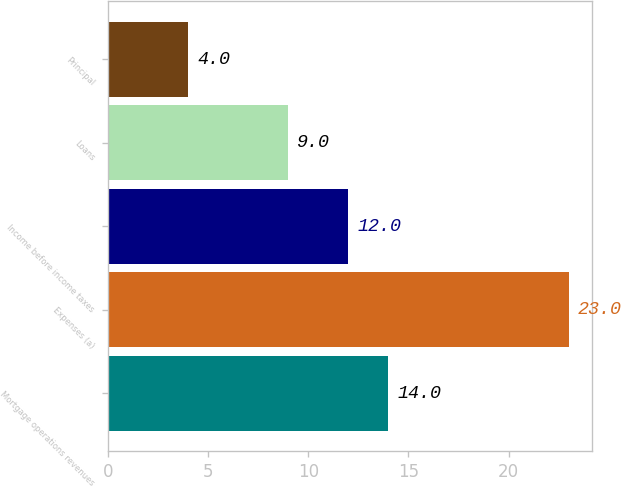Convert chart to OTSL. <chart><loc_0><loc_0><loc_500><loc_500><bar_chart><fcel>Mortgage operations revenues<fcel>Expenses (a)<fcel>Income before income taxes<fcel>Loans<fcel>Principal<nl><fcel>14<fcel>23<fcel>12<fcel>9<fcel>4<nl></chart> 